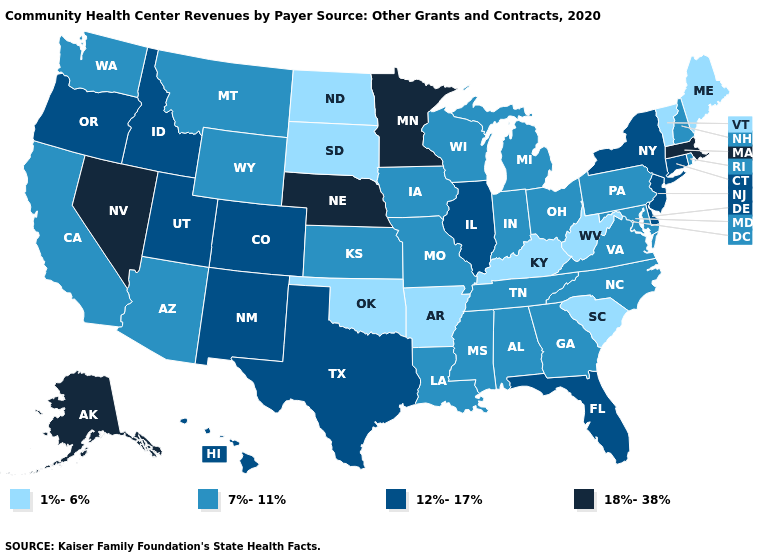What is the value of Louisiana?
Write a very short answer. 7%-11%. Does Maine have the lowest value in the USA?
Short answer required. Yes. What is the value of Delaware?
Write a very short answer. 12%-17%. What is the highest value in states that border Louisiana?
Write a very short answer. 12%-17%. Name the states that have a value in the range 7%-11%?
Give a very brief answer. Alabama, Arizona, California, Georgia, Indiana, Iowa, Kansas, Louisiana, Maryland, Michigan, Mississippi, Missouri, Montana, New Hampshire, North Carolina, Ohio, Pennsylvania, Rhode Island, Tennessee, Virginia, Washington, Wisconsin, Wyoming. What is the value of New York?
Answer briefly. 12%-17%. What is the value of Minnesota?
Write a very short answer. 18%-38%. Name the states that have a value in the range 7%-11%?
Write a very short answer. Alabama, Arizona, California, Georgia, Indiana, Iowa, Kansas, Louisiana, Maryland, Michigan, Mississippi, Missouri, Montana, New Hampshire, North Carolina, Ohio, Pennsylvania, Rhode Island, Tennessee, Virginia, Washington, Wisconsin, Wyoming. What is the value of Mississippi?
Write a very short answer. 7%-11%. Does Vermont have the same value as North Dakota?
Be succinct. Yes. Does the map have missing data?
Give a very brief answer. No. Does Oregon have the lowest value in the USA?
Write a very short answer. No. Which states hav the highest value in the West?
Short answer required. Alaska, Nevada. Does California have the lowest value in the USA?
Be succinct. No. Name the states that have a value in the range 12%-17%?
Quick response, please. Colorado, Connecticut, Delaware, Florida, Hawaii, Idaho, Illinois, New Jersey, New Mexico, New York, Oregon, Texas, Utah. 